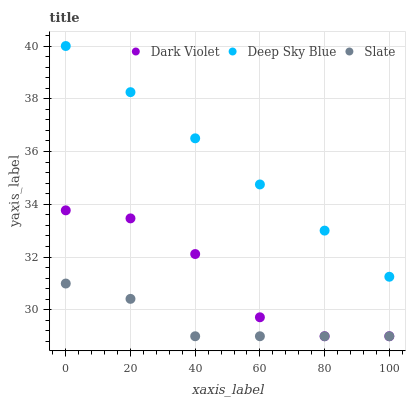Does Slate have the minimum area under the curve?
Answer yes or no. Yes. Does Deep Sky Blue have the maximum area under the curve?
Answer yes or no. Yes. Does Dark Violet have the minimum area under the curve?
Answer yes or no. No. Does Dark Violet have the maximum area under the curve?
Answer yes or no. No. Is Deep Sky Blue the smoothest?
Answer yes or no. Yes. Is Dark Violet the roughest?
Answer yes or no. Yes. Is Dark Violet the smoothest?
Answer yes or no. No. Is Deep Sky Blue the roughest?
Answer yes or no. No. Does Slate have the lowest value?
Answer yes or no. Yes. Does Deep Sky Blue have the lowest value?
Answer yes or no. No. Does Deep Sky Blue have the highest value?
Answer yes or no. Yes. Does Dark Violet have the highest value?
Answer yes or no. No. Is Dark Violet less than Deep Sky Blue?
Answer yes or no. Yes. Is Deep Sky Blue greater than Dark Violet?
Answer yes or no. Yes. Does Dark Violet intersect Slate?
Answer yes or no. Yes. Is Dark Violet less than Slate?
Answer yes or no. No. Is Dark Violet greater than Slate?
Answer yes or no. No. Does Dark Violet intersect Deep Sky Blue?
Answer yes or no. No. 